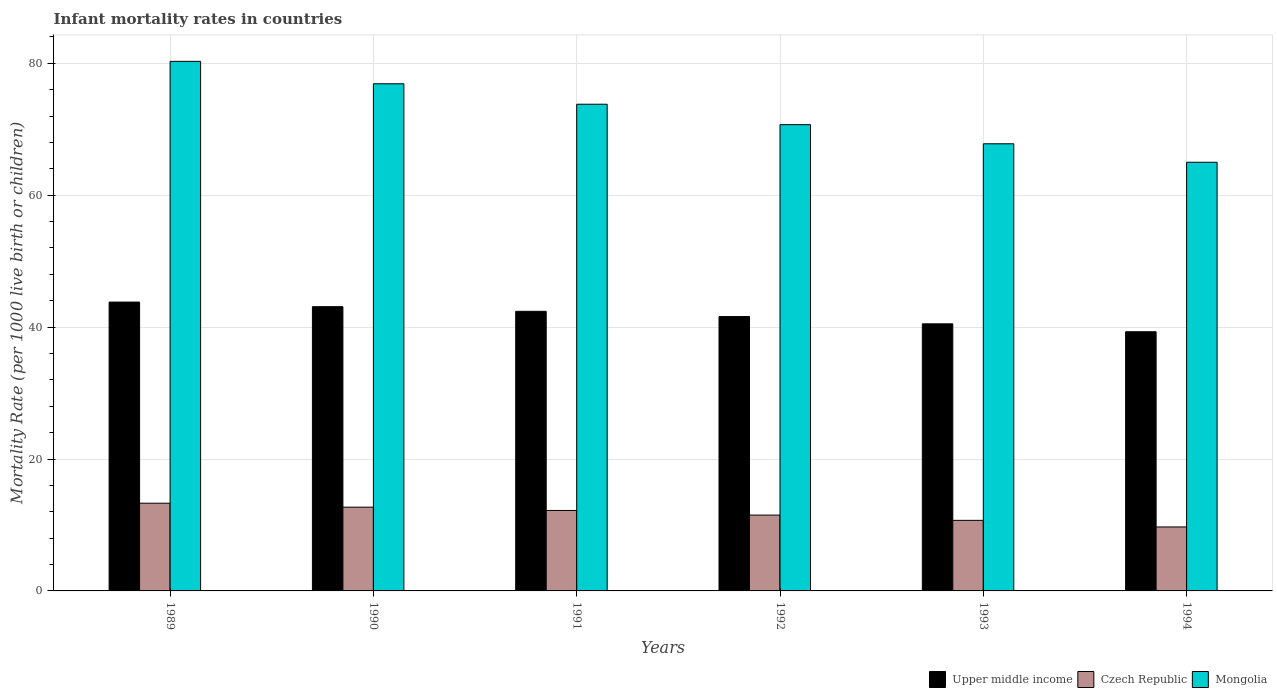How many different coloured bars are there?
Keep it short and to the point. 3. How many groups of bars are there?
Keep it short and to the point. 6. Are the number of bars per tick equal to the number of legend labels?
Ensure brevity in your answer.  Yes. Are the number of bars on each tick of the X-axis equal?
Your response must be concise. Yes. How many bars are there on the 5th tick from the left?
Give a very brief answer. 3. In how many cases, is the number of bars for a given year not equal to the number of legend labels?
Your response must be concise. 0. Across all years, what is the maximum infant mortality rate in Upper middle income?
Keep it short and to the point. 43.8. In which year was the infant mortality rate in Upper middle income minimum?
Provide a short and direct response. 1994. What is the total infant mortality rate in Mongolia in the graph?
Provide a short and direct response. 434.5. What is the difference between the infant mortality rate in Czech Republic in 1989 and that in 1994?
Offer a very short reply. 3.6. What is the difference between the infant mortality rate in Upper middle income in 1991 and the infant mortality rate in Mongolia in 1994?
Offer a very short reply. -22.6. What is the average infant mortality rate in Czech Republic per year?
Provide a succinct answer. 11.68. In the year 1989, what is the difference between the infant mortality rate in Czech Republic and infant mortality rate in Mongolia?
Your response must be concise. -67. In how many years, is the infant mortality rate in Czech Republic greater than 64?
Your answer should be very brief. 0. What is the ratio of the infant mortality rate in Mongolia in 1992 to that in 1993?
Offer a terse response. 1.04. Is the infant mortality rate in Upper middle income in 1989 less than that in 1993?
Provide a succinct answer. No. Is the difference between the infant mortality rate in Czech Republic in 1989 and 1990 greater than the difference between the infant mortality rate in Mongolia in 1989 and 1990?
Offer a terse response. No. What is the difference between the highest and the second highest infant mortality rate in Upper middle income?
Provide a short and direct response. 0.7. What is the difference between the highest and the lowest infant mortality rate in Mongolia?
Give a very brief answer. 15.3. In how many years, is the infant mortality rate in Czech Republic greater than the average infant mortality rate in Czech Republic taken over all years?
Offer a terse response. 3. Is the sum of the infant mortality rate in Czech Republic in 1989 and 1991 greater than the maximum infant mortality rate in Upper middle income across all years?
Offer a terse response. No. What does the 2nd bar from the left in 1992 represents?
Your answer should be compact. Czech Republic. What does the 2nd bar from the right in 1992 represents?
Provide a short and direct response. Czech Republic. Is it the case that in every year, the sum of the infant mortality rate in Upper middle income and infant mortality rate in Mongolia is greater than the infant mortality rate in Czech Republic?
Offer a very short reply. Yes. How many years are there in the graph?
Ensure brevity in your answer.  6. Are the values on the major ticks of Y-axis written in scientific E-notation?
Offer a very short reply. No. Does the graph contain any zero values?
Ensure brevity in your answer.  No. Does the graph contain grids?
Ensure brevity in your answer.  Yes. What is the title of the graph?
Your answer should be very brief. Infant mortality rates in countries. Does "Upper middle income" appear as one of the legend labels in the graph?
Offer a terse response. Yes. What is the label or title of the Y-axis?
Your answer should be very brief. Mortality Rate (per 1000 live birth or children). What is the Mortality Rate (per 1000 live birth or children) in Upper middle income in 1989?
Offer a very short reply. 43.8. What is the Mortality Rate (per 1000 live birth or children) in Czech Republic in 1989?
Your answer should be very brief. 13.3. What is the Mortality Rate (per 1000 live birth or children) in Mongolia in 1989?
Provide a short and direct response. 80.3. What is the Mortality Rate (per 1000 live birth or children) in Upper middle income in 1990?
Ensure brevity in your answer.  43.1. What is the Mortality Rate (per 1000 live birth or children) of Mongolia in 1990?
Your response must be concise. 76.9. What is the Mortality Rate (per 1000 live birth or children) of Upper middle income in 1991?
Provide a succinct answer. 42.4. What is the Mortality Rate (per 1000 live birth or children) of Mongolia in 1991?
Your answer should be compact. 73.8. What is the Mortality Rate (per 1000 live birth or children) of Upper middle income in 1992?
Give a very brief answer. 41.6. What is the Mortality Rate (per 1000 live birth or children) of Mongolia in 1992?
Your answer should be very brief. 70.7. What is the Mortality Rate (per 1000 live birth or children) in Upper middle income in 1993?
Your answer should be compact. 40.5. What is the Mortality Rate (per 1000 live birth or children) in Mongolia in 1993?
Your answer should be very brief. 67.8. What is the Mortality Rate (per 1000 live birth or children) of Upper middle income in 1994?
Offer a terse response. 39.3. What is the Mortality Rate (per 1000 live birth or children) of Czech Republic in 1994?
Keep it short and to the point. 9.7. What is the Mortality Rate (per 1000 live birth or children) in Mongolia in 1994?
Give a very brief answer. 65. Across all years, what is the maximum Mortality Rate (per 1000 live birth or children) in Upper middle income?
Ensure brevity in your answer.  43.8. Across all years, what is the maximum Mortality Rate (per 1000 live birth or children) of Mongolia?
Make the answer very short. 80.3. Across all years, what is the minimum Mortality Rate (per 1000 live birth or children) in Upper middle income?
Ensure brevity in your answer.  39.3. What is the total Mortality Rate (per 1000 live birth or children) of Upper middle income in the graph?
Provide a short and direct response. 250.7. What is the total Mortality Rate (per 1000 live birth or children) of Czech Republic in the graph?
Your answer should be compact. 70.1. What is the total Mortality Rate (per 1000 live birth or children) of Mongolia in the graph?
Keep it short and to the point. 434.5. What is the difference between the Mortality Rate (per 1000 live birth or children) in Upper middle income in 1989 and that in 1990?
Your answer should be compact. 0.7. What is the difference between the Mortality Rate (per 1000 live birth or children) of Upper middle income in 1989 and that in 1991?
Your response must be concise. 1.4. What is the difference between the Mortality Rate (per 1000 live birth or children) in Czech Republic in 1989 and that in 1991?
Offer a very short reply. 1.1. What is the difference between the Mortality Rate (per 1000 live birth or children) of Mongolia in 1989 and that in 1991?
Your answer should be very brief. 6.5. What is the difference between the Mortality Rate (per 1000 live birth or children) in Mongolia in 1989 and that in 1992?
Your answer should be very brief. 9.6. What is the difference between the Mortality Rate (per 1000 live birth or children) of Upper middle income in 1989 and that in 1993?
Your answer should be compact. 3.3. What is the difference between the Mortality Rate (per 1000 live birth or children) in Mongolia in 1989 and that in 1993?
Your answer should be very brief. 12.5. What is the difference between the Mortality Rate (per 1000 live birth or children) in Czech Republic in 1989 and that in 1994?
Give a very brief answer. 3.6. What is the difference between the Mortality Rate (per 1000 live birth or children) in Mongolia in 1989 and that in 1994?
Make the answer very short. 15.3. What is the difference between the Mortality Rate (per 1000 live birth or children) in Upper middle income in 1990 and that in 1991?
Ensure brevity in your answer.  0.7. What is the difference between the Mortality Rate (per 1000 live birth or children) of Czech Republic in 1990 and that in 1991?
Offer a very short reply. 0.5. What is the difference between the Mortality Rate (per 1000 live birth or children) in Mongolia in 1990 and that in 1991?
Make the answer very short. 3.1. What is the difference between the Mortality Rate (per 1000 live birth or children) of Czech Republic in 1990 and that in 1992?
Offer a terse response. 1.2. What is the difference between the Mortality Rate (per 1000 live birth or children) of Upper middle income in 1990 and that in 1993?
Provide a short and direct response. 2.6. What is the difference between the Mortality Rate (per 1000 live birth or children) in Czech Republic in 1990 and that in 1993?
Provide a succinct answer. 2. What is the difference between the Mortality Rate (per 1000 live birth or children) of Mongolia in 1990 and that in 1993?
Your response must be concise. 9.1. What is the difference between the Mortality Rate (per 1000 live birth or children) in Czech Republic in 1990 and that in 1994?
Your response must be concise. 3. What is the difference between the Mortality Rate (per 1000 live birth or children) in Mongolia in 1990 and that in 1994?
Keep it short and to the point. 11.9. What is the difference between the Mortality Rate (per 1000 live birth or children) in Upper middle income in 1991 and that in 1992?
Provide a succinct answer. 0.8. What is the difference between the Mortality Rate (per 1000 live birth or children) of Czech Republic in 1991 and that in 1992?
Give a very brief answer. 0.7. What is the difference between the Mortality Rate (per 1000 live birth or children) of Mongolia in 1991 and that in 1992?
Your answer should be very brief. 3.1. What is the difference between the Mortality Rate (per 1000 live birth or children) in Upper middle income in 1991 and that in 1993?
Keep it short and to the point. 1.9. What is the difference between the Mortality Rate (per 1000 live birth or children) in Czech Republic in 1991 and that in 1993?
Your answer should be very brief. 1.5. What is the difference between the Mortality Rate (per 1000 live birth or children) of Mongolia in 1991 and that in 1993?
Your response must be concise. 6. What is the difference between the Mortality Rate (per 1000 live birth or children) of Czech Republic in 1991 and that in 1994?
Your response must be concise. 2.5. What is the difference between the Mortality Rate (per 1000 live birth or children) of Upper middle income in 1992 and that in 1993?
Ensure brevity in your answer.  1.1. What is the difference between the Mortality Rate (per 1000 live birth or children) of Czech Republic in 1992 and that in 1993?
Your response must be concise. 0.8. What is the difference between the Mortality Rate (per 1000 live birth or children) of Mongolia in 1992 and that in 1993?
Make the answer very short. 2.9. What is the difference between the Mortality Rate (per 1000 live birth or children) of Upper middle income in 1992 and that in 1994?
Provide a short and direct response. 2.3. What is the difference between the Mortality Rate (per 1000 live birth or children) of Upper middle income in 1993 and that in 1994?
Offer a very short reply. 1.2. What is the difference between the Mortality Rate (per 1000 live birth or children) of Czech Republic in 1993 and that in 1994?
Give a very brief answer. 1. What is the difference between the Mortality Rate (per 1000 live birth or children) in Upper middle income in 1989 and the Mortality Rate (per 1000 live birth or children) in Czech Republic in 1990?
Give a very brief answer. 31.1. What is the difference between the Mortality Rate (per 1000 live birth or children) in Upper middle income in 1989 and the Mortality Rate (per 1000 live birth or children) in Mongolia in 1990?
Give a very brief answer. -33.1. What is the difference between the Mortality Rate (per 1000 live birth or children) of Czech Republic in 1989 and the Mortality Rate (per 1000 live birth or children) of Mongolia in 1990?
Your answer should be compact. -63.6. What is the difference between the Mortality Rate (per 1000 live birth or children) of Upper middle income in 1989 and the Mortality Rate (per 1000 live birth or children) of Czech Republic in 1991?
Offer a very short reply. 31.6. What is the difference between the Mortality Rate (per 1000 live birth or children) in Upper middle income in 1989 and the Mortality Rate (per 1000 live birth or children) in Mongolia in 1991?
Your answer should be very brief. -30. What is the difference between the Mortality Rate (per 1000 live birth or children) in Czech Republic in 1989 and the Mortality Rate (per 1000 live birth or children) in Mongolia in 1991?
Provide a short and direct response. -60.5. What is the difference between the Mortality Rate (per 1000 live birth or children) of Upper middle income in 1989 and the Mortality Rate (per 1000 live birth or children) of Czech Republic in 1992?
Keep it short and to the point. 32.3. What is the difference between the Mortality Rate (per 1000 live birth or children) of Upper middle income in 1989 and the Mortality Rate (per 1000 live birth or children) of Mongolia in 1992?
Provide a succinct answer. -26.9. What is the difference between the Mortality Rate (per 1000 live birth or children) of Czech Republic in 1989 and the Mortality Rate (per 1000 live birth or children) of Mongolia in 1992?
Your answer should be compact. -57.4. What is the difference between the Mortality Rate (per 1000 live birth or children) in Upper middle income in 1989 and the Mortality Rate (per 1000 live birth or children) in Czech Republic in 1993?
Provide a short and direct response. 33.1. What is the difference between the Mortality Rate (per 1000 live birth or children) of Czech Republic in 1989 and the Mortality Rate (per 1000 live birth or children) of Mongolia in 1993?
Make the answer very short. -54.5. What is the difference between the Mortality Rate (per 1000 live birth or children) of Upper middle income in 1989 and the Mortality Rate (per 1000 live birth or children) of Czech Republic in 1994?
Your answer should be very brief. 34.1. What is the difference between the Mortality Rate (per 1000 live birth or children) of Upper middle income in 1989 and the Mortality Rate (per 1000 live birth or children) of Mongolia in 1994?
Offer a very short reply. -21.2. What is the difference between the Mortality Rate (per 1000 live birth or children) of Czech Republic in 1989 and the Mortality Rate (per 1000 live birth or children) of Mongolia in 1994?
Ensure brevity in your answer.  -51.7. What is the difference between the Mortality Rate (per 1000 live birth or children) of Upper middle income in 1990 and the Mortality Rate (per 1000 live birth or children) of Czech Republic in 1991?
Your response must be concise. 30.9. What is the difference between the Mortality Rate (per 1000 live birth or children) of Upper middle income in 1990 and the Mortality Rate (per 1000 live birth or children) of Mongolia in 1991?
Give a very brief answer. -30.7. What is the difference between the Mortality Rate (per 1000 live birth or children) in Czech Republic in 1990 and the Mortality Rate (per 1000 live birth or children) in Mongolia in 1991?
Offer a terse response. -61.1. What is the difference between the Mortality Rate (per 1000 live birth or children) of Upper middle income in 1990 and the Mortality Rate (per 1000 live birth or children) of Czech Republic in 1992?
Offer a terse response. 31.6. What is the difference between the Mortality Rate (per 1000 live birth or children) in Upper middle income in 1990 and the Mortality Rate (per 1000 live birth or children) in Mongolia in 1992?
Your answer should be compact. -27.6. What is the difference between the Mortality Rate (per 1000 live birth or children) of Czech Republic in 1990 and the Mortality Rate (per 1000 live birth or children) of Mongolia in 1992?
Your answer should be very brief. -58. What is the difference between the Mortality Rate (per 1000 live birth or children) in Upper middle income in 1990 and the Mortality Rate (per 1000 live birth or children) in Czech Republic in 1993?
Provide a short and direct response. 32.4. What is the difference between the Mortality Rate (per 1000 live birth or children) in Upper middle income in 1990 and the Mortality Rate (per 1000 live birth or children) in Mongolia in 1993?
Offer a terse response. -24.7. What is the difference between the Mortality Rate (per 1000 live birth or children) of Czech Republic in 1990 and the Mortality Rate (per 1000 live birth or children) of Mongolia in 1993?
Ensure brevity in your answer.  -55.1. What is the difference between the Mortality Rate (per 1000 live birth or children) in Upper middle income in 1990 and the Mortality Rate (per 1000 live birth or children) in Czech Republic in 1994?
Your answer should be very brief. 33.4. What is the difference between the Mortality Rate (per 1000 live birth or children) in Upper middle income in 1990 and the Mortality Rate (per 1000 live birth or children) in Mongolia in 1994?
Offer a terse response. -21.9. What is the difference between the Mortality Rate (per 1000 live birth or children) of Czech Republic in 1990 and the Mortality Rate (per 1000 live birth or children) of Mongolia in 1994?
Your answer should be compact. -52.3. What is the difference between the Mortality Rate (per 1000 live birth or children) of Upper middle income in 1991 and the Mortality Rate (per 1000 live birth or children) of Czech Republic in 1992?
Offer a terse response. 30.9. What is the difference between the Mortality Rate (per 1000 live birth or children) in Upper middle income in 1991 and the Mortality Rate (per 1000 live birth or children) in Mongolia in 1992?
Provide a succinct answer. -28.3. What is the difference between the Mortality Rate (per 1000 live birth or children) of Czech Republic in 1991 and the Mortality Rate (per 1000 live birth or children) of Mongolia in 1992?
Ensure brevity in your answer.  -58.5. What is the difference between the Mortality Rate (per 1000 live birth or children) in Upper middle income in 1991 and the Mortality Rate (per 1000 live birth or children) in Czech Republic in 1993?
Your answer should be compact. 31.7. What is the difference between the Mortality Rate (per 1000 live birth or children) of Upper middle income in 1991 and the Mortality Rate (per 1000 live birth or children) of Mongolia in 1993?
Offer a very short reply. -25.4. What is the difference between the Mortality Rate (per 1000 live birth or children) of Czech Republic in 1991 and the Mortality Rate (per 1000 live birth or children) of Mongolia in 1993?
Your answer should be compact. -55.6. What is the difference between the Mortality Rate (per 1000 live birth or children) of Upper middle income in 1991 and the Mortality Rate (per 1000 live birth or children) of Czech Republic in 1994?
Your response must be concise. 32.7. What is the difference between the Mortality Rate (per 1000 live birth or children) of Upper middle income in 1991 and the Mortality Rate (per 1000 live birth or children) of Mongolia in 1994?
Make the answer very short. -22.6. What is the difference between the Mortality Rate (per 1000 live birth or children) in Czech Republic in 1991 and the Mortality Rate (per 1000 live birth or children) in Mongolia in 1994?
Offer a terse response. -52.8. What is the difference between the Mortality Rate (per 1000 live birth or children) in Upper middle income in 1992 and the Mortality Rate (per 1000 live birth or children) in Czech Republic in 1993?
Make the answer very short. 30.9. What is the difference between the Mortality Rate (per 1000 live birth or children) in Upper middle income in 1992 and the Mortality Rate (per 1000 live birth or children) in Mongolia in 1993?
Make the answer very short. -26.2. What is the difference between the Mortality Rate (per 1000 live birth or children) of Czech Republic in 1992 and the Mortality Rate (per 1000 live birth or children) of Mongolia in 1993?
Offer a very short reply. -56.3. What is the difference between the Mortality Rate (per 1000 live birth or children) of Upper middle income in 1992 and the Mortality Rate (per 1000 live birth or children) of Czech Republic in 1994?
Make the answer very short. 31.9. What is the difference between the Mortality Rate (per 1000 live birth or children) of Upper middle income in 1992 and the Mortality Rate (per 1000 live birth or children) of Mongolia in 1994?
Offer a very short reply. -23.4. What is the difference between the Mortality Rate (per 1000 live birth or children) of Czech Republic in 1992 and the Mortality Rate (per 1000 live birth or children) of Mongolia in 1994?
Offer a terse response. -53.5. What is the difference between the Mortality Rate (per 1000 live birth or children) of Upper middle income in 1993 and the Mortality Rate (per 1000 live birth or children) of Czech Republic in 1994?
Offer a terse response. 30.8. What is the difference between the Mortality Rate (per 1000 live birth or children) of Upper middle income in 1993 and the Mortality Rate (per 1000 live birth or children) of Mongolia in 1994?
Provide a succinct answer. -24.5. What is the difference between the Mortality Rate (per 1000 live birth or children) of Czech Republic in 1993 and the Mortality Rate (per 1000 live birth or children) of Mongolia in 1994?
Offer a terse response. -54.3. What is the average Mortality Rate (per 1000 live birth or children) of Upper middle income per year?
Offer a terse response. 41.78. What is the average Mortality Rate (per 1000 live birth or children) in Czech Republic per year?
Your answer should be compact. 11.68. What is the average Mortality Rate (per 1000 live birth or children) of Mongolia per year?
Provide a short and direct response. 72.42. In the year 1989, what is the difference between the Mortality Rate (per 1000 live birth or children) of Upper middle income and Mortality Rate (per 1000 live birth or children) of Czech Republic?
Your answer should be compact. 30.5. In the year 1989, what is the difference between the Mortality Rate (per 1000 live birth or children) of Upper middle income and Mortality Rate (per 1000 live birth or children) of Mongolia?
Make the answer very short. -36.5. In the year 1989, what is the difference between the Mortality Rate (per 1000 live birth or children) in Czech Republic and Mortality Rate (per 1000 live birth or children) in Mongolia?
Your answer should be compact. -67. In the year 1990, what is the difference between the Mortality Rate (per 1000 live birth or children) in Upper middle income and Mortality Rate (per 1000 live birth or children) in Czech Republic?
Your answer should be very brief. 30.4. In the year 1990, what is the difference between the Mortality Rate (per 1000 live birth or children) of Upper middle income and Mortality Rate (per 1000 live birth or children) of Mongolia?
Offer a very short reply. -33.8. In the year 1990, what is the difference between the Mortality Rate (per 1000 live birth or children) in Czech Republic and Mortality Rate (per 1000 live birth or children) in Mongolia?
Offer a very short reply. -64.2. In the year 1991, what is the difference between the Mortality Rate (per 1000 live birth or children) in Upper middle income and Mortality Rate (per 1000 live birth or children) in Czech Republic?
Provide a succinct answer. 30.2. In the year 1991, what is the difference between the Mortality Rate (per 1000 live birth or children) of Upper middle income and Mortality Rate (per 1000 live birth or children) of Mongolia?
Your answer should be compact. -31.4. In the year 1991, what is the difference between the Mortality Rate (per 1000 live birth or children) of Czech Republic and Mortality Rate (per 1000 live birth or children) of Mongolia?
Make the answer very short. -61.6. In the year 1992, what is the difference between the Mortality Rate (per 1000 live birth or children) in Upper middle income and Mortality Rate (per 1000 live birth or children) in Czech Republic?
Make the answer very short. 30.1. In the year 1992, what is the difference between the Mortality Rate (per 1000 live birth or children) in Upper middle income and Mortality Rate (per 1000 live birth or children) in Mongolia?
Give a very brief answer. -29.1. In the year 1992, what is the difference between the Mortality Rate (per 1000 live birth or children) of Czech Republic and Mortality Rate (per 1000 live birth or children) of Mongolia?
Ensure brevity in your answer.  -59.2. In the year 1993, what is the difference between the Mortality Rate (per 1000 live birth or children) of Upper middle income and Mortality Rate (per 1000 live birth or children) of Czech Republic?
Offer a very short reply. 29.8. In the year 1993, what is the difference between the Mortality Rate (per 1000 live birth or children) in Upper middle income and Mortality Rate (per 1000 live birth or children) in Mongolia?
Provide a succinct answer. -27.3. In the year 1993, what is the difference between the Mortality Rate (per 1000 live birth or children) in Czech Republic and Mortality Rate (per 1000 live birth or children) in Mongolia?
Ensure brevity in your answer.  -57.1. In the year 1994, what is the difference between the Mortality Rate (per 1000 live birth or children) in Upper middle income and Mortality Rate (per 1000 live birth or children) in Czech Republic?
Offer a very short reply. 29.6. In the year 1994, what is the difference between the Mortality Rate (per 1000 live birth or children) in Upper middle income and Mortality Rate (per 1000 live birth or children) in Mongolia?
Keep it short and to the point. -25.7. In the year 1994, what is the difference between the Mortality Rate (per 1000 live birth or children) of Czech Republic and Mortality Rate (per 1000 live birth or children) of Mongolia?
Your response must be concise. -55.3. What is the ratio of the Mortality Rate (per 1000 live birth or children) in Upper middle income in 1989 to that in 1990?
Your answer should be compact. 1.02. What is the ratio of the Mortality Rate (per 1000 live birth or children) of Czech Republic in 1989 to that in 1990?
Provide a succinct answer. 1.05. What is the ratio of the Mortality Rate (per 1000 live birth or children) in Mongolia in 1989 to that in 1990?
Ensure brevity in your answer.  1.04. What is the ratio of the Mortality Rate (per 1000 live birth or children) of Upper middle income in 1989 to that in 1991?
Provide a short and direct response. 1.03. What is the ratio of the Mortality Rate (per 1000 live birth or children) in Czech Republic in 1989 to that in 1991?
Your response must be concise. 1.09. What is the ratio of the Mortality Rate (per 1000 live birth or children) in Mongolia in 1989 to that in 1991?
Ensure brevity in your answer.  1.09. What is the ratio of the Mortality Rate (per 1000 live birth or children) in Upper middle income in 1989 to that in 1992?
Keep it short and to the point. 1.05. What is the ratio of the Mortality Rate (per 1000 live birth or children) in Czech Republic in 1989 to that in 1992?
Give a very brief answer. 1.16. What is the ratio of the Mortality Rate (per 1000 live birth or children) of Mongolia in 1989 to that in 1992?
Ensure brevity in your answer.  1.14. What is the ratio of the Mortality Rate (per 1000 live birth or children) in Upper middle income in 1989 to that in 1993?
Offer a very short reply. 1.08. What is the ratio of the Mortality Rate (per 1000 live birth or children) of Czech Republic in 1989 to that in 1993?
Offer a terse response. 1.24. What is the ratio of the Mortality Rate (per 1000 live birth or children) in Mongolia in 1989 to that in 1993?
Provide a succinct answer. 1.18. What is the ratio of the Mortality Rate (per 1000 live birth or children) in Upper middle income in 1989 to that in 1994?
Provide a succinct answer. 1.11. What is the ratio of the Mortality Rate (per 1000 live birth or children) in Czech Republic in 1989 to that in 1994?
Your answer should be compact. 1.37. What is the ratio of the Mortality Rate (per 1000 live birth or children) in Mongolia in 1989 to that in 1994?
Provide a short and direct response. 1.24. What is the ratio of the Mortality Rate (per 1000 live birth or children) in Upper middle income in 1990 to that in 1991?
Offer a terse response. 1.02. What is the ratio of the Mortality Rate (per 1000 live birth or children) in Czech Republic in 1990 to that in 1991?
Give a very brief answer. 1.04. What is the ratio of the Mortality Rate (per 1000 live birth or children) in Mongolia in 1990 to that in 1991?
Keep it short and to the point. 1.04. What is the ratio of the Mortality Rate (per 1000 live birth or children) of Upper middle income in 1990 to that in 1992?
Provide a short and direct response. 1.04. What is the ratio of the Mortality Rate (per 1000 live birth or children) of Czech Republic in 1990 to that in 1992?
Offer a terse response. 1.1. What is the ratio of the Mortality Rate (per 1000 live birth or children) in Mongolia in 1990 to that in 1992?
Provide a succinct answer. 1.09. What is the ratio of the Mortality Rate (per 1000 live birth or children) of Upper middle income in 1990 to that in 1993?
Your answer should be very brief. 1.06. What is the ratio of the Mortality Rate (per 1000 live birth or children) of Czech Republic in 1990 to that in 1993?
Provide a short and direct response. 1.19. What is the ratio of the Mortality Rate (per 1000 live birth or children) in Mongolia in 1990 to that in 1993?
Ensure brevity in your answer.  1.13. What is the ratio of the Mortality Rate (per 1000 live birth or children) of Upper middle income in 1990 to that in 1994?
Your answer should be very brief. 1.1. What is the ratio of the Mortality Rate (per 1000 live birth or children) of Czech Republic in 1990 to that in 1994?
Offer a very short reply. 1.31. What is the ratio of the Mortality Rate (per 1000 live birth or children) in Mongolia in 1990 to that in 1994?
Your answer should be compact. 1.18. What is the ratio of the Mortality Rate (per 1000 live birth or children) of Upper middle income in 1991 to that in 1992?
Offer a terse response. 1.02. What is the ratio of the Mortality Rate (per 1000 live birth or children) of Czech Republic in 1991 to that in 1992?
Your answer should be very brief. 1.06. What is the ratio of the Mortality Rate (per 1000 live birth or children) of Mongolia in 1991 to that in 1992?
Your answer should be compact. 1.04. What is the ratio of the Mortality Rate (per 1000 live birth or children) of Upper middle income in 1991 to that in 1993?
Your answer should be compact. 1.05. What is the ratio of the Mortality Rate (per 1000 live birth or children) in Czech Republic in 1991 to that in 1993?
Offer a very short reply. 1.14. What is the ratio of the Mortality Rate (per 1000 live birth or children) in Mongolia in 1991 to that in 1993?
Provide a short and direct response. 1.09. What is the ratio of the Mortality Rate (per 1000 live birth or children) of Upper middle income in 1991 to that in 1994?
Provide a short and direct response. 1.08. What is the ratio of the Mortality Rate (per 1000 live birth or children) of Czech Republic in 1991 to that in 1994?
Your answer should be very brief. 1.26. What is the ratio of the Mortality Rate (per 1000 live birth or children) in Mongolia in 1991 to that in 1994?
Ensure brevity in your answer.  1.14. What is the ratio of the Mortality Rate (per 1000 live birth or children) in Upper middle income in 1992 to that in 1993?
Keep it short and to the point. 1.03. What is the ratio of the Mortality Rate (per 1000 live birth or children) in Czech Republic in 1992 to that in 1993?
Offer a very short reply. 1.07. What is the ratio of the Mortality Rate (per 1000 live birth or children) in Mongolia in 1992 to that in 1993?
Make the answer very short. 1.04. What is the ratio of the Mortality Rate (per 1000 live birth or children) of Upper middle income in 1992 to that in 1994?
Offer a terse response. 1.06. What is the ratio of the Mortality Rate (per 1000 live birth or children) in Czech Republic in 1992 to that in 1994?
Your answer should be very brief. 1.19. What is the ratio of the Mortality Rate (per 1000 live birth or children) in Mongolia in 1992 to that in 1994?
Make the answer very short. 1.09. What is the ratio of the Mortality Rate (per 1000 live birth or children) of Upper middle income in 1993 to that in 1994?
Give a very brief answer. 1.03. What is the ratio of the Mortality Rate (per 1000 live birth or children) of Czech Republic in 1993 to that in 1994?
Your answer should be compact. 1.1. What is the ratio of the Mortality Rate (per 1000 live birth or children) of Mongolia in 1993 to that in 1994?
Your answer should be compact. 1.04. What is the difference between the highest and the second highest Mortality Rate (per 1000 live birth or children) in Czech Republic?
Offer a very short reply. 0.6. What is the difference between the highest and the second highest Mortality Rate (per 1000 live birth or children) in Mongolia?
Offer a very short reply. 3.4. What is the difference between the highest and the lowest Mortality Rate (per 1000 live birth or children) in Mongolia?
Provide a short and direct response. 15.3. 